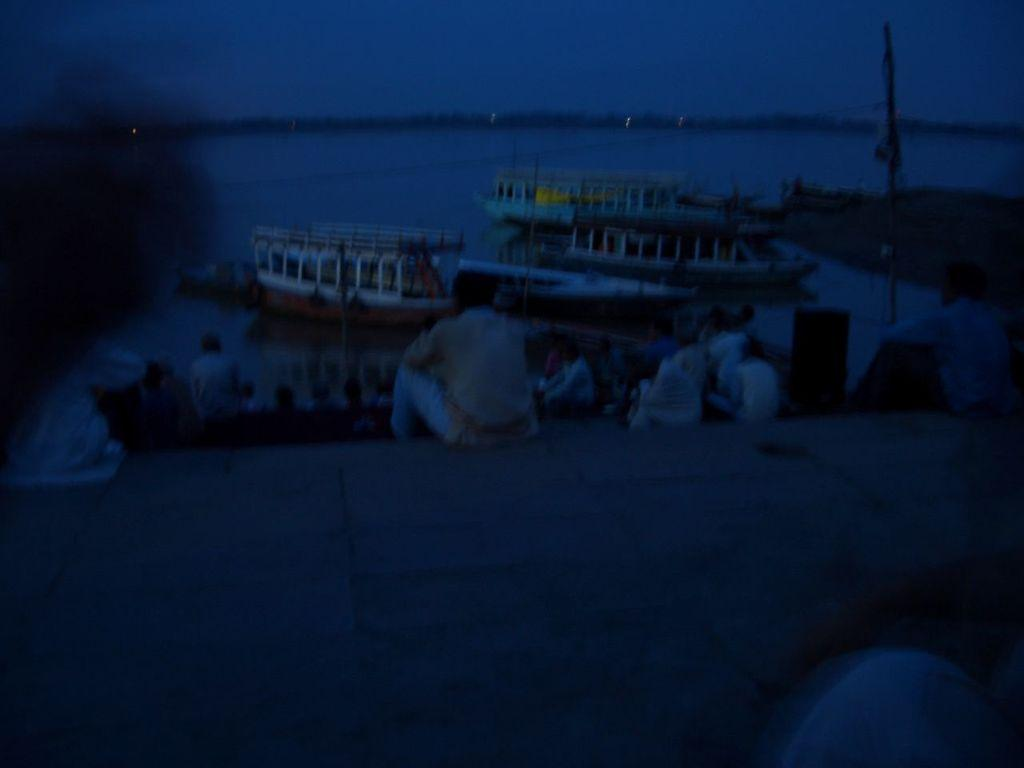What is in the water in the image? There are boats in the water in the image. What can be seen in front of the boats? There is a group of people in front of the boats. What is visible at the top of the image? The sky is visible at the top of the image. What is located on the right side of the image? There is a pole on the right side of the image. Where is the nearest hospital to the location of the boats in the image? The provided facts do not mention a hospital or its location, so it cannot be determined from the image. Can you see any corn growing near the boats in the image? There is no corn visible in the image; it features boats in the water and a group of people. 